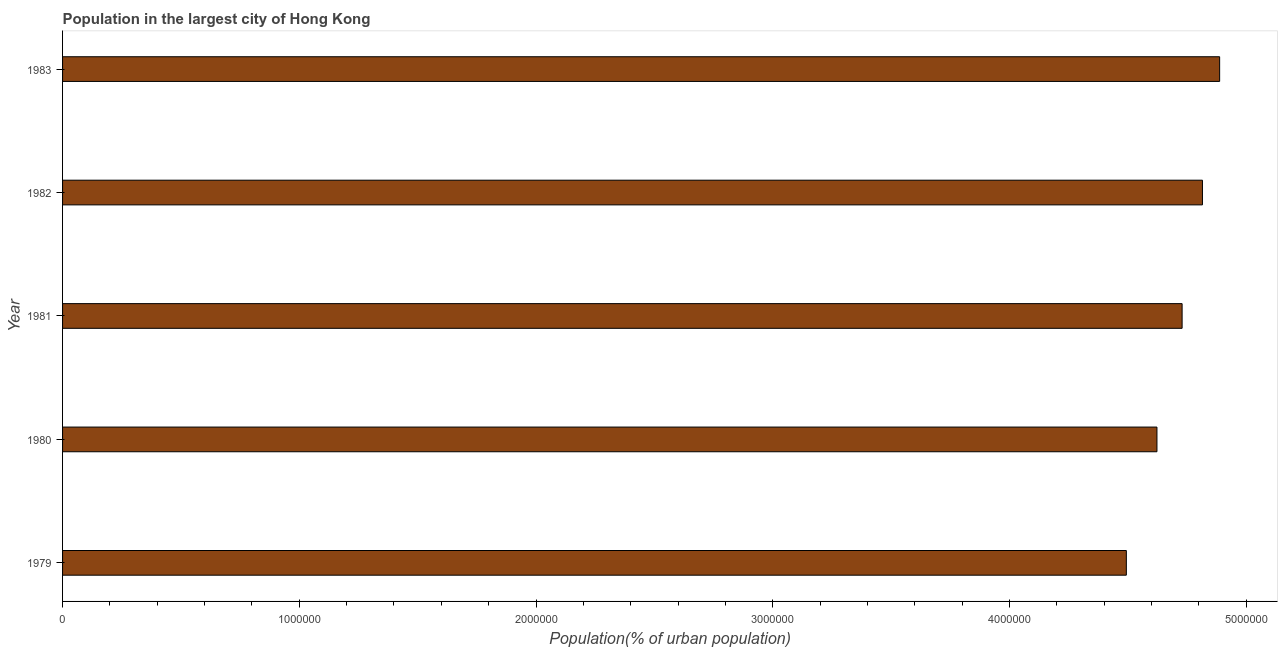Does the graph contain any zero values?
Provide a short and direct response. No. What is the title of the graph?
Make the answer very short. Population in the largest city of Hong Kong. What is the label or title of the X-axis?
Your answer should be compact. Population(% of urban population). What is the population in largest city in 1980?
Provide a succinct answer. 4.62e+06. Across all years, what is the maximum population in largest city?
Make the answer very short. 4.89e+06. Across all years, what is the minimum population in largest city?
Your response must be concise. 4.49e+06. In which year was the population in largest city minimum?
Give a very brief answer. 1979. What is the sum of the population in largest city?
Your answer should be compact. 2.35e+07. What is the difference between the population in largest city in 1980 and 1982?
Your response must be concise. -1.92e+05. What is the average population in largest city per year?
Your answer should be very brief. 4.71e+06. What is the median population in largest city?
Keep it short and to the point. 4.73e+06. In how many years, is the population in largest city greater than 800000 %?
Provide a succinct answer. 5. Do a majority of the years between 1980 and 1979 (inclusive) have population in largest city greater than 4200000 %?
Give a very brief answer. No. What is the ratio of the population in largest city in 1980 to that in 1983?
Your answer should be very brief. 0.95. Is the population in largest city in 1979 less than that in 1980?
Keep it short and to the point. Yes. What is the difference between the highest and the second highest population in largest city?
Your answer should be compact. 7.26e+04. What is the difference between the highest and the lowest population in largest city?
Offer a very short reply. 3.94e+05. In how many years, is the population in largest city greater than the average population in largest city taken over all years?
Your answer should be very brief. 3. How many bars are there?
Provide a short and direct response. 5. How many years are there in the graph?
Your answer should be very brief. 5. What is the difference between two consecutive major ticks on the X-axis?
Keep it short and to the point. 1.00e+06. What is the Population(% of urban population) of 1979?
Offer a very short reply. 4.49e+06. What is the Population(% of urban population) of 1980?
Your answer should be very brief. 4.62e+06. What is the Population(% of urban population) in 1981?
Provide a short and direct response. 4.73e+06. What is the Population(% of urban population) of 1982?
Ensure brevity in your answer.  4.82e+06. What is the Population(% of urban population) of 1983?
Your answer should be very brief. 4.89e+06. What is the difference between the Population(% of urban population) in 1979 and 1980?
Give a very brief answer. -1.29e+05. What is the difference between the Population(% of urban population) in 1979 and 1981?
Offer a terse response. -2.36e+05. What is the difference between the Population(% of urban population) in 1979 and 1982?
Provide a succinct answer. -3.21e+05. What is the difference between the Population(% of urban population) in 1979 and 1983?
Offer a very short reply. -3.94e+05. What is the difference between the Population(% of urban population) in 1980 and 1981?
Provide a short and direct response. -1.06e+05. What is the difference between the Population(% of urban population) in 1980 and 1982?
Offer a terse response. -1.92e+05. What is the difference between the Population(% of urban population) in 1980 and 1983?
Provide a succinct answer. -2.65e+05. What is the difference between the Population(% of urban population) in 1981 and 1982?
Offer a terse response. -8.59e+04. What is the difference between the Population(% of urban population) in 1981 and 1983?
Keep it short and to the point. -1.59e+05. What is the difference between the Population(% of urban population) in 1982 and 1983?
Make the answer very short. -7.26e+04. What is the ratio of the Population(% of urban population) in 1979 to that in 1980?
Your response must be concise. 0.97. What is the ratio of the Population(% of urban population) in 1979 to that in 1981?
Keep it short and to the point. 0.95. What is the ratio of the Population(% of urban population) in 1979 to that in 1982?
Make the answer very short. 0.93. What is the ratio of the Population(% of urban population) in 1979 to that in 1983?
Ensure brevity in your answer.  0.92. What is the ratio of the Population(% of urban population) in 1980 to that in 1981?
Your response must be concise. 0.98. What is the ratio of the Population(% of urban population) in 1980 to that in 1983?
Provide a short and direct response. 0.95. What is the ratio of the Population(% of urban population) in 1981 to that in 1983?
Keep it short and to the point. 0.97. 